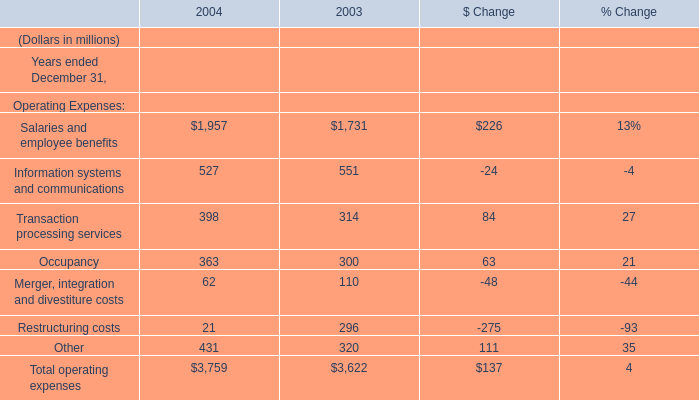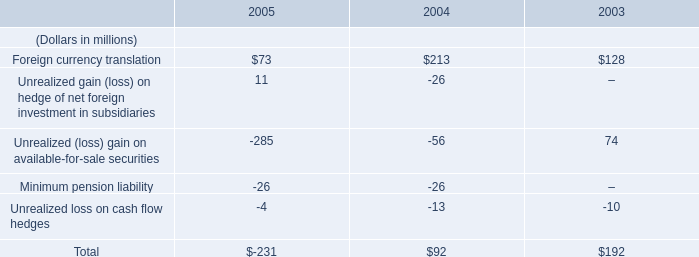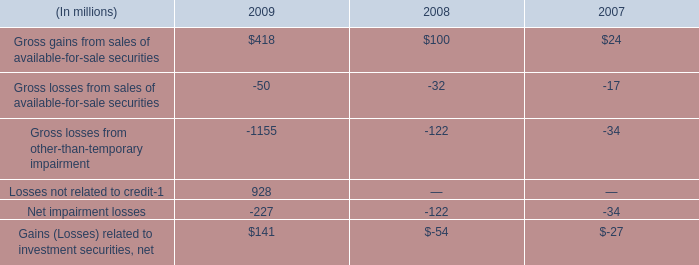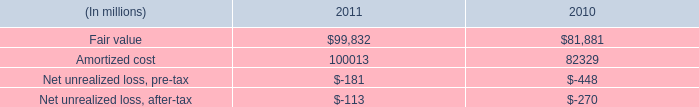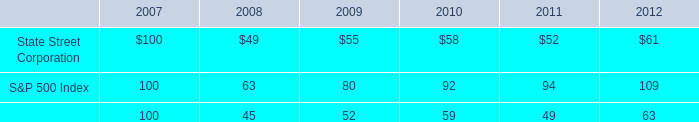what is the roi of an investment in s&p500 index from 2007 to 2009? 
Computations: ((80 - 100) / 100)
Answer: -0.2. 